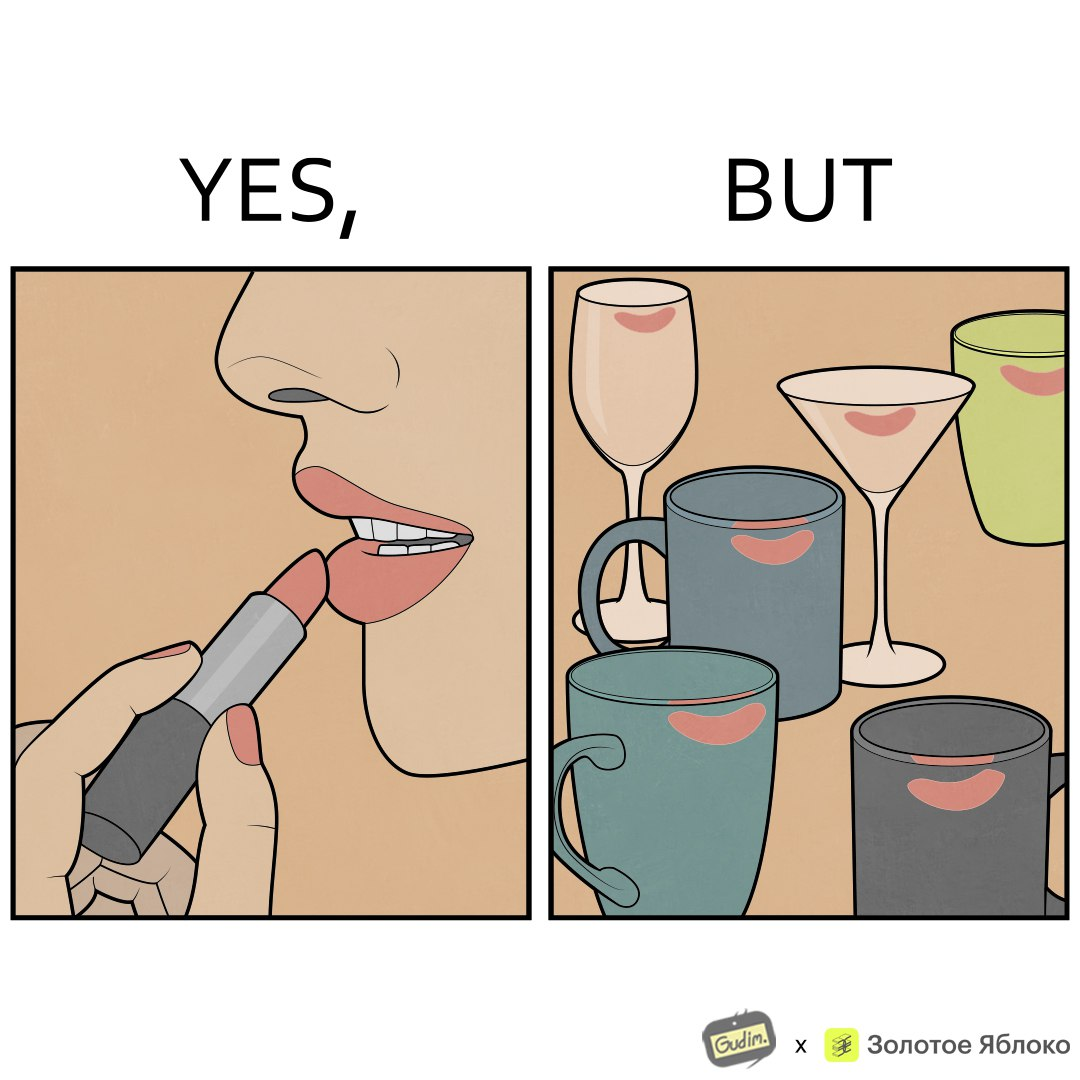Is there satirical content in this image? Yes, this image is satirical. 